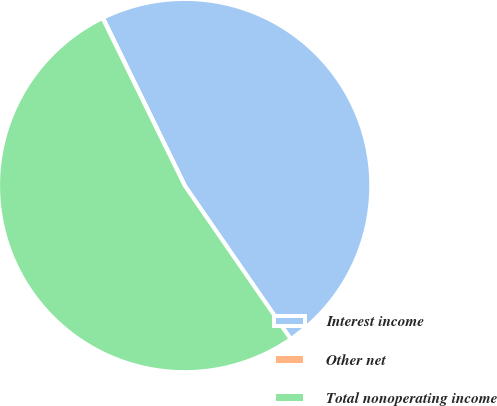Convert chart. <chart><loc_0><loc_0><loc_500><loc_500><pie_chart><fcel>Interest income<fcel>Other net<fcel>Total nonoperating income<nl><fcel>47.6%<fcel>0.04%<fcel>52.36%<nl></chart> 